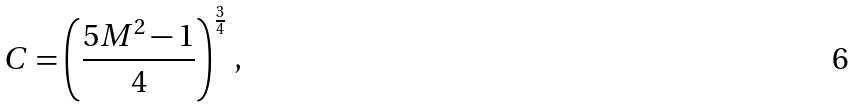<formula> <loc_0><loc_0><loc_500><loc_500>C = \left ( \frac { 5 M ^ { 2 } - 1 } { 4 } \right ) ^ { \frac { 3 } { 4 } } \, ,</formula> 